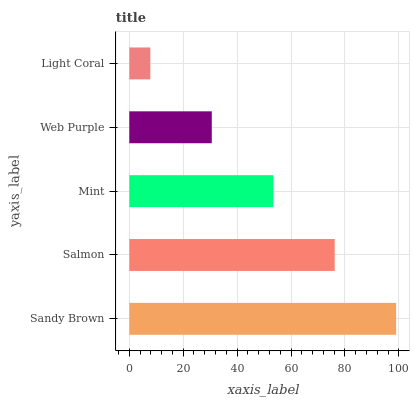Is Light Coral the minimum?
Answer yes or no. Yes. Is Sandy Brown the maximum?
Answer yes or no. Yes. Is Salmon the minimum?
Answer yes or no. No. Is Salmon the maximum?
Answer yes or no. No. Is Sandy Brown greater than Salmon?
Answer yes or no. Yes. Is Salmon less than Sandy Brown?
Answer yes or no. Yes. Is Salmon greater than Sandy Brown?
Answer yes or no. No. Is Sandy Brown less than Salmon?
Answer yes or no. No. Is Mint the high median?
Answer yes or no. Yes. Is Mint the low median?
Answer yes or no. Yes. Is Sandy Brown the high median?
Answer yes or no. No. Is Salmon the low median?
Answer yes or no. No. 